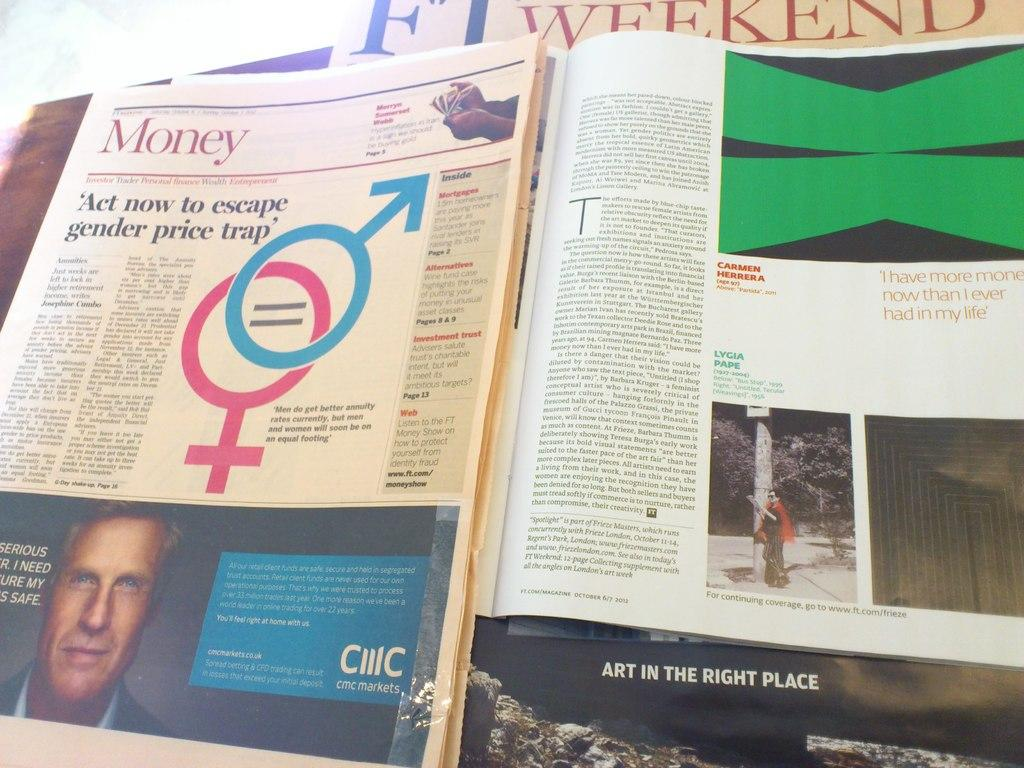What type of reading material can be seen in the image? There is a newspaper and a magazine in the image. Can you describe the two types of reading materials in the image? The newspaper is a collection of news articles and the magazine is a periodical publication containing articles, stories, and images. What type of machine is depicted in the image? There is no machine present in the image; it only features a newspaper and a magazine. Is there a fight happening in the image? There is no fight depicted in the image; it only features a newspaper and a magazine. 